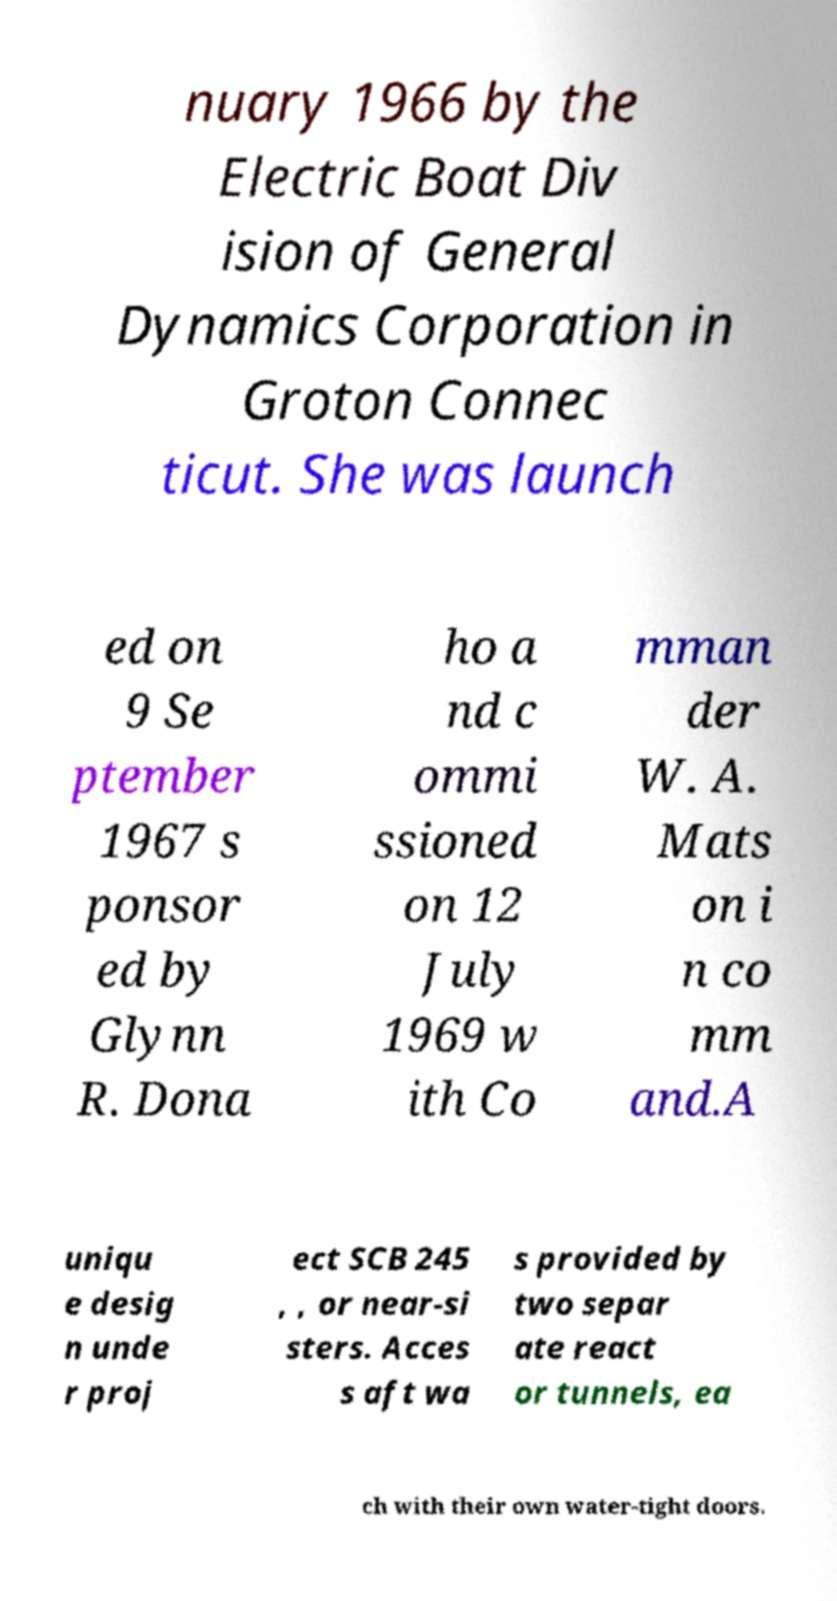Can you accurately transcribe the text from the provided image for me? nuary 1966 by the Electric Boat Div ision of General Dynamics Corporation in Groton Connec ticut. She was launch ed on 9 Se ptember 1967 s ponsor ed by Glynn R. Dona ho a nd c ommi ssioned on 12 July 1969 w ith Co mman der W. A. Mats on i n co mm and.A uniqu e desig n unde r proj ect SCB 245 , , or near-si sters. Acces s aft wa s provided by two separ ate react or tunnels, ea ch with their own water-tight doors. 